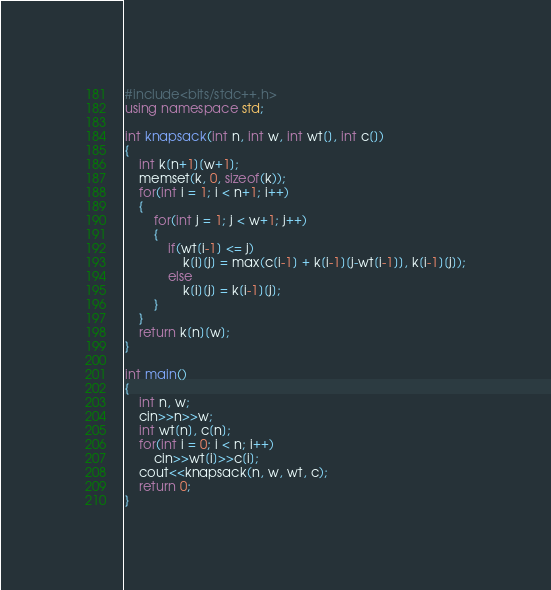Convert code to text. <code><loc_0><loc_0><loc_500><loc_500><_C++_>#include<bits/stdc++.h>
using namespace std;

int knapsack(int n, int w, int wt[], int c[])
{
  	int k[n+1][w+1];
  	memset(k, 0, sizeof(k));
	for(int i = 1; i < n+1; i++)
    {
    	for(int j = 1; j < w+1; j++)
        {
        	if(wt[i-1] <= j)
              	k[i][j] = max(c[i-1] + k[i-1][j-wt[i-1]], k[i-1][j]);
          	else
              	k[i][j] = k[i-1][j];
        }
    }
    return k[n][w];
}

int main()
{
  	int n, w;
  	cin>>n>>w;
  	int wt[n], c[n];
  	for(int i = 0; i < n; i++)
    	cin>>wt[i]>>c[i];
  	cout<<knapsack(n, w, wt, c);
	return 0;
}
</code> 